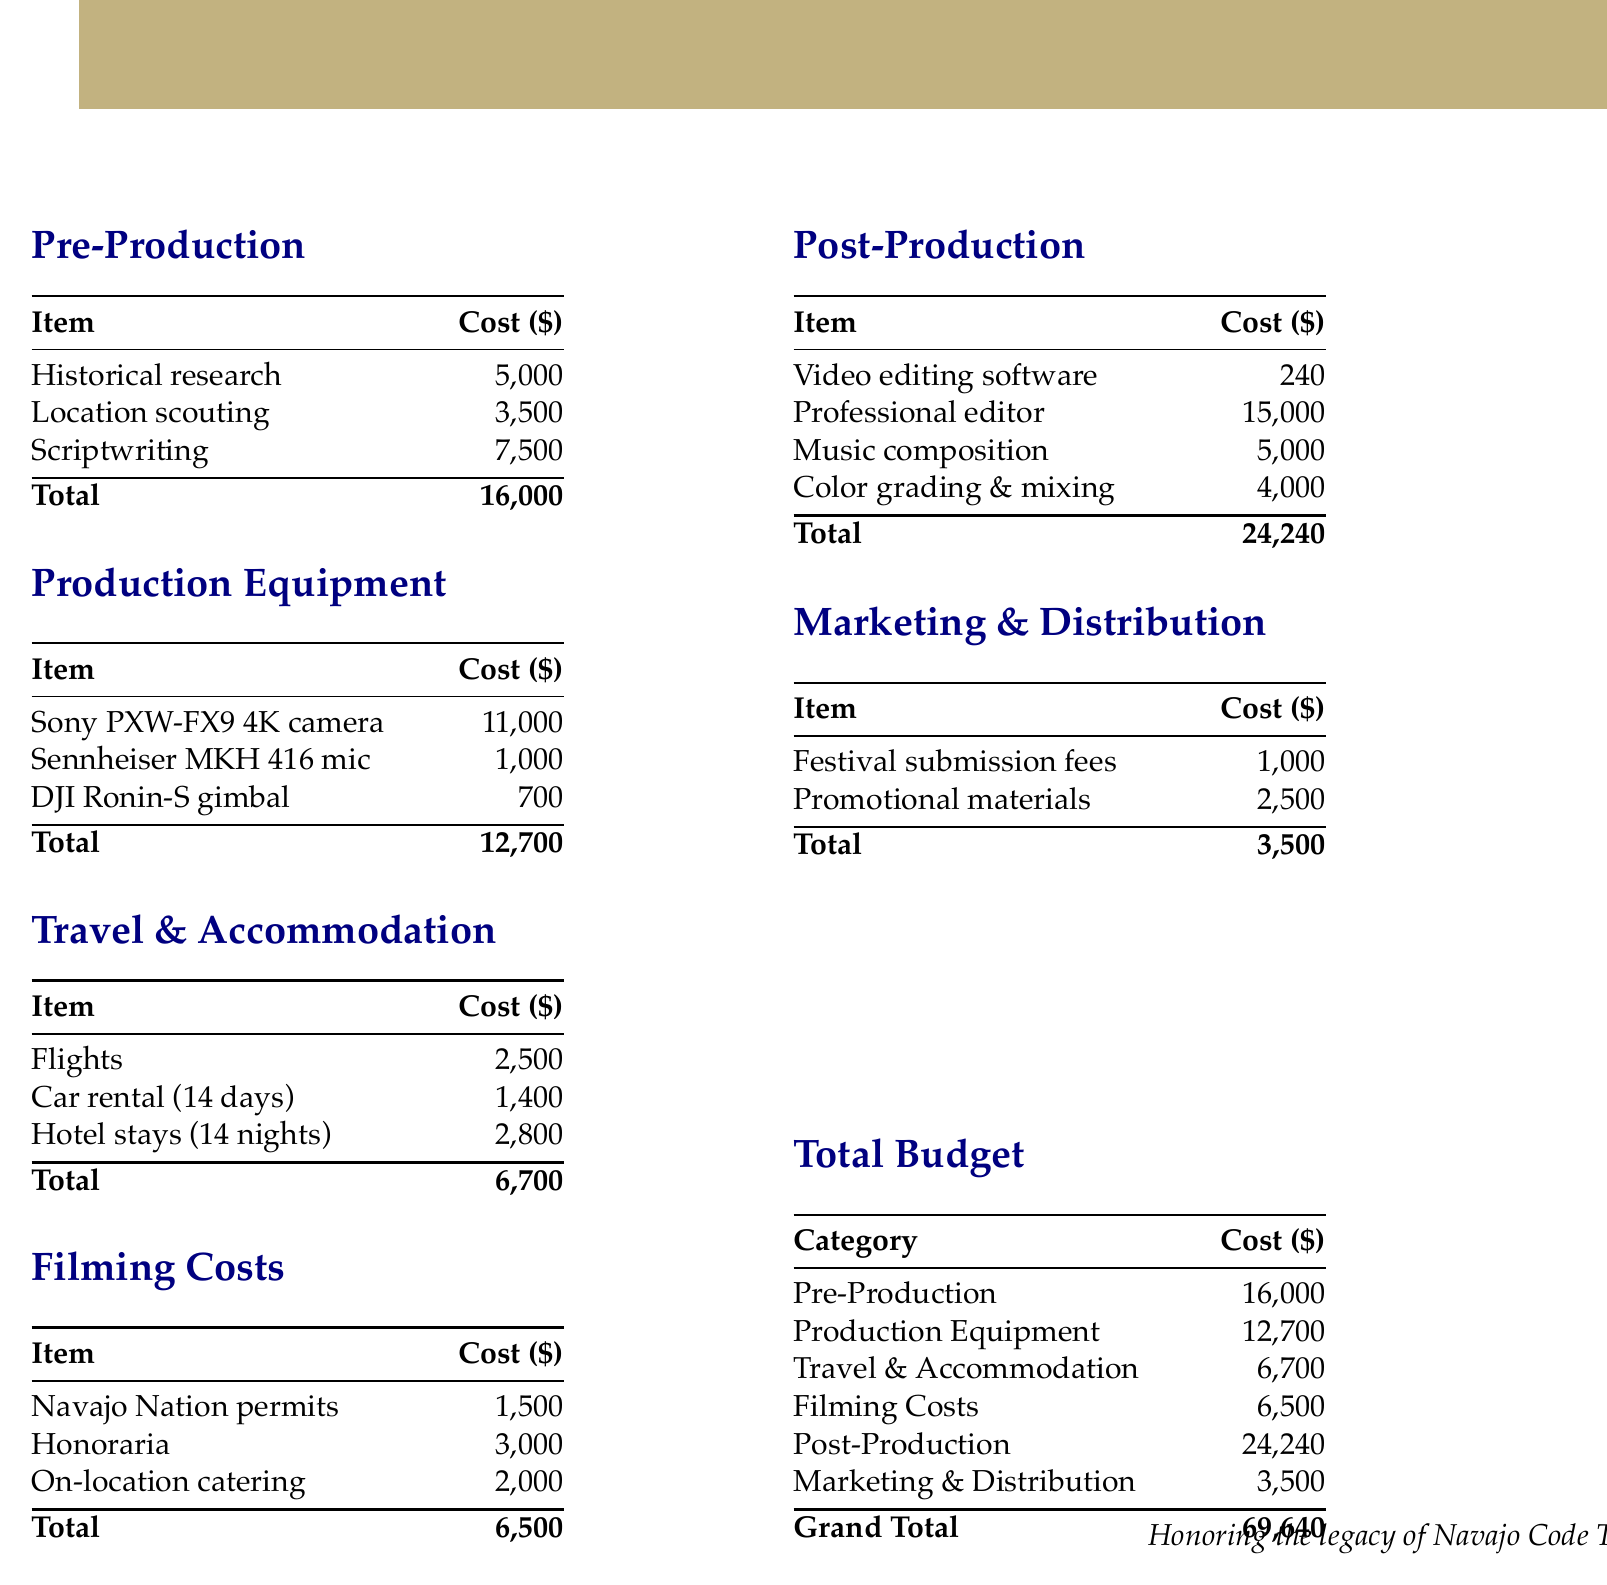What is the total cost for Pre-Production? The total cost for Pre-Production is listed at $16,000.
Answer: $16,000 What is the cost of the Sony PXW-FX9 4K camera? The cost for the Sony PXW-FX9 4K camera is specifically mentioned as $11,000.
Answer: $11,000 How much is allocated for Travel & Accommodation? The document states the allocation for Travel & Accommodation is $6,700.
Answer: $6,700 What is the total for Post-Production? The total for Post-Production is provided as $24,240.
Answer: $24,240 What is the Grand Total of the budget? The Grand Total of the budget is clearly stated as $69,640.
Answer: $69,640 What are the costs associated with filming permits? The costs associated with filming permits are specified as $1,500.
Answer: $1,500 How much funding is earmarked for Marketing & Distribution? The document outlines the funding for Marketing & Distribution as $3,500.
Answer: $3,500 What is the cost for professional editing? The cost for professional editing is indicated to be $15,000.
Answer: $15,000 How many nights are included in the hotel stay budget? The document notes that the hotel stays are budgeted for 14 nights.
Answer: 14 nights 